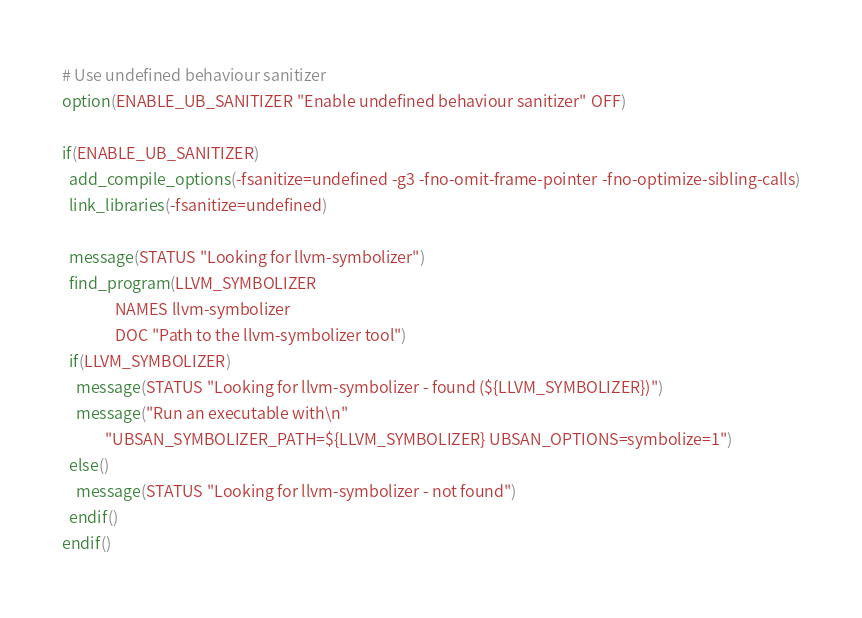Convert code to text. <code><loc_0><loc_0><loc_500><loc_500><_CMake_># Use undefined behaviour sanitizer
option(ENABLE_UB_SANITIZER "Enable undefined behaviour sanitizer" OFF)

if(ENABLE_UB_SANITIZER)
  add_compile_options(-fsanitize=undefined -g3 -fno-omit-frame-pointer -fno-optimize-sibling-calls)
  link_libraries(-fsanitize=undefined)

  message(STATUS "Looking for llvm-symbolizer")
  find_program(LLVM_SYMBOLIZER
               NAMES llvm-symbolizer
               DOC "Path to the llvm-symbolizer tool")
  if(LLVM_SYMBOLIZER)
    message(STATUS "Looking for llvm-symbolizer - found (${LLVM_SYMBOLIZER})")
    message("Run an executable with\n"
            "UBSAN_SYMBOLIZER_PATH=${LLVM_SYMBOLIZER} UBSAN_OPTIONS=symbolize=1")
  else()
    message(STATUS "Looking for llvm-symbolizer - not found")
  endif()
endif()
</code> 